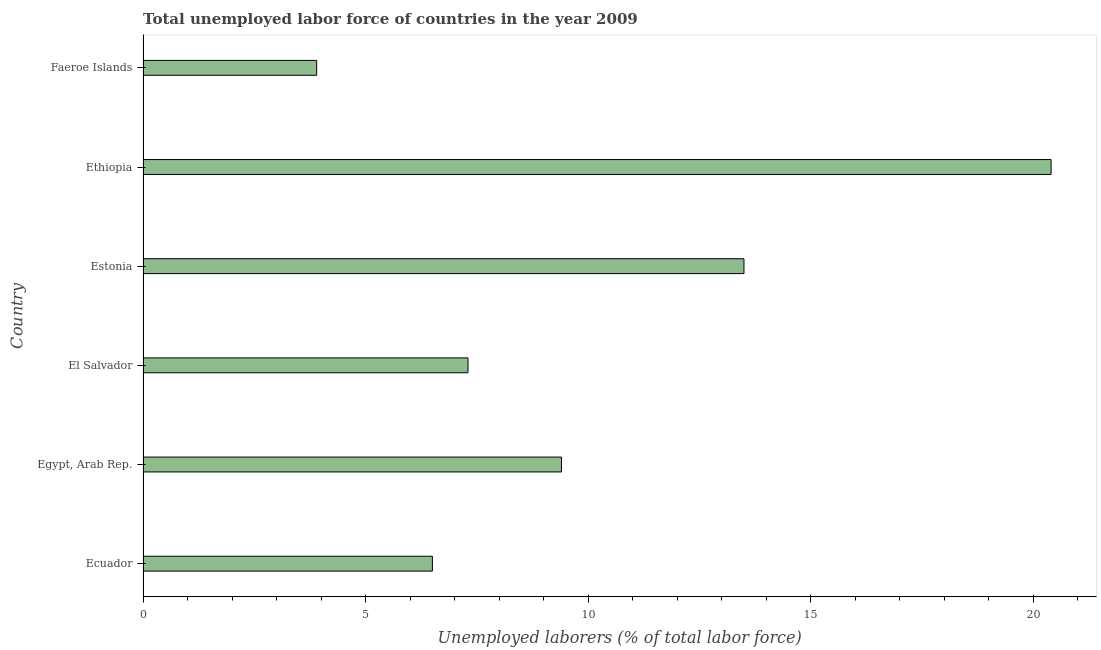Does the graph contain grids?
Provide a succinct answer. No. What is the title of the graph?
Offer a very short reply. Total unemployed labor force of countries in the year 2009. What is the label or title of the X-axis?
Your answer should be very brief. Unemployed laborers (% of total labor force). What is the label or title of the Y-axis?
Give a very brief answer. Country. What is the total unemployed labour force in Egypt, Arab Rep.?
Give a very brief answer. 9.4. Across all countries, what is the maximum total unemployed labour force?
Give a very brief answer. 20.4. Across all countries, what is the minimum total unemployed labour force?
Offer a very short reply. 3.9. In which country was the total unemployed labour force maximum?
Your answer should be compact. Ethiopia. In which country was the total unemployed labour force minimum?
Provide a short and direct response. Faeroe Islands. What is the sum of the total unemployed labour force?
Provide a succinct answer. 61. What is the difference between the total unemployed labour force in Egypt, Arab Rep. and El Salvador?
Your response must be concise. 2.1. What is the average total unemployed labour force per country?
Offer a very short reply. 10.17. What is the median total unemployed labour force?
Keep it short and to the point. 8.35. In how many countries, is the total unemployed labour force greater than 13 %?
Offer a terse response. 2. What is the ratio of the total unemployed labour force in El Salvador to that in Estonia?
Provide a short and direct response. 0.54. What is the difference between the highest and the second highest total unemployed labour force?
Your answer should be compact. 6.9. Is the sum of the total unemployed labour force in El Salvador and Estonia greater than the maximum total unemployed labour force across all countries?
Keep it short and to the point. Yes. What is the difference between the highest and the lowest total unemployed labour force?
Provide a succinct answer. 16.5. What is the Unemployed laborers (% of total labor force) of Egypt, Arab Rep.?
Your answer should be compact. 9.4. What is the Unemployed laborers (% of total labor force) in El Salvador?
Keep it short and to the point. 7.3. What is the Unemployed laborers (% of total labor force) of Ethiopia?
Your response must be concise. 20.4. What is the Unemployed laborers (% of total labor force) in Faeroe Islands?
Your answer should be compact. 3.9. What is the difference between the Unemployed laborers (% of total labor force) in Ecuador and Egypt, Arab Rep.?
Your answer should be compact. -2.9. What is the difference between the Unemployed laborers (% of total labor force) in Ecuador and Ethiopia?
Your answer should be compact. -13.9. What is the difference between the Unemployed laborers (% of total labor force) in Egypt, Arab Rep. and Estonia?
Provide a short and direct response. -4.1. What is the difference between the Unemployed laborers (% of total labor force) in Egypt, Arab Rep. and Ethiopia?
Provide a succinct answer. -11. What is the difference between the Unemployed laborers (% of total labor force) in El Salvador and Estonia?
Your response must be concise. -6.2. What is the difference between the Unemployed laborers (% of total labor force) in El Salvador and Ethiopia?
Your response must be concise. -13.1. What is the difference between the Unemployed laborers (% of total labor force) in El Salvador and Faeroe Islands?
Offer a terse response. 3.4. What is the difference between the Unemployed laborers (% of total labor force) in Estonia and Ethiopia?
Provide a succinct answer. -6.9. What is the difference between the Unemployed laborers (% of total labor force) in Estonia and Faeroe Islands?
Make the answer very short. 9.6. What is the ratio of the Unemployed laborers (% of total labor force) in Ecuador to that in Egypt, Arab Rep.?
Your response must be concise. 0.69. What is the ratio of the Unemployed laborers (% of total labor force) in Ecuador to that in El Salvador?
Keep it short and to the point. 0.89. What is the ratio of the Unemployed laborers (% of total labor force) in Ecuador to that in Estonia?
Ensure brevity in your answer.  0.48. What is the ratio of the Unemployed laborers (% of total labor force) in Ecuador to that in Ethiopia?
Give a very brief answer. 0.32. What is the ratio of the Unemployed laborers (% of total labor force) in Ecuador to that in Faeroe Islands?
Provide a succinct answer. 1.67. What is the ratio of the Unemployed laborers (% of total labor force) in Egypt, Arab Rep. to that in El Salvador?
Provide a succinct answer. 1.29. What is the ratio of the Unemployed laborers (% of total labor force) in Egypt, Arab Rep. to that in Estonia?
Provide a short and direct response. 0.7. What is the ratio of the Unemployed laborers (% of total labor force) in Egypt, Arab Rep. to that in Ethiopia?
Keep it short and to the point. 0.46. What is the ratio of the Unemployed laborers (% of total labor force) in Egypt, Arab Rep. to that in Faeroe Islands?
Offer a terse response. 2.41. What is the ratio of the Unemployed laborers (% of total labor force) in El Salvador to that in Estonia?
Offer a terse response. 0.54. What is the ratio of the Unemployed laborers (% of total labor force) in El Salvador to that in Ethiopia?
Keep it short and to the point. 0.36. What is the ratio of the Unemployed laborers (% of total labor force) in El Salvador to that in Faeroe Islands?
Your answer should be very brief. 1.87. What is the ratio of the Unemployed laborers (% of total labor force) in Estonia to that in Ethiopia?
Ensure brevity in your answer.  0.66. What is the ratio of the Unemployed laborers (% of total labor force) in Estonia to that in Faeroe Islands?
Offer a terse response. 3.46. What is the ratio of the Unemployed laborers (% of total labor force) in Ethiopia to that in Faeroe Islands?
Your response must be concise. 5.23. 